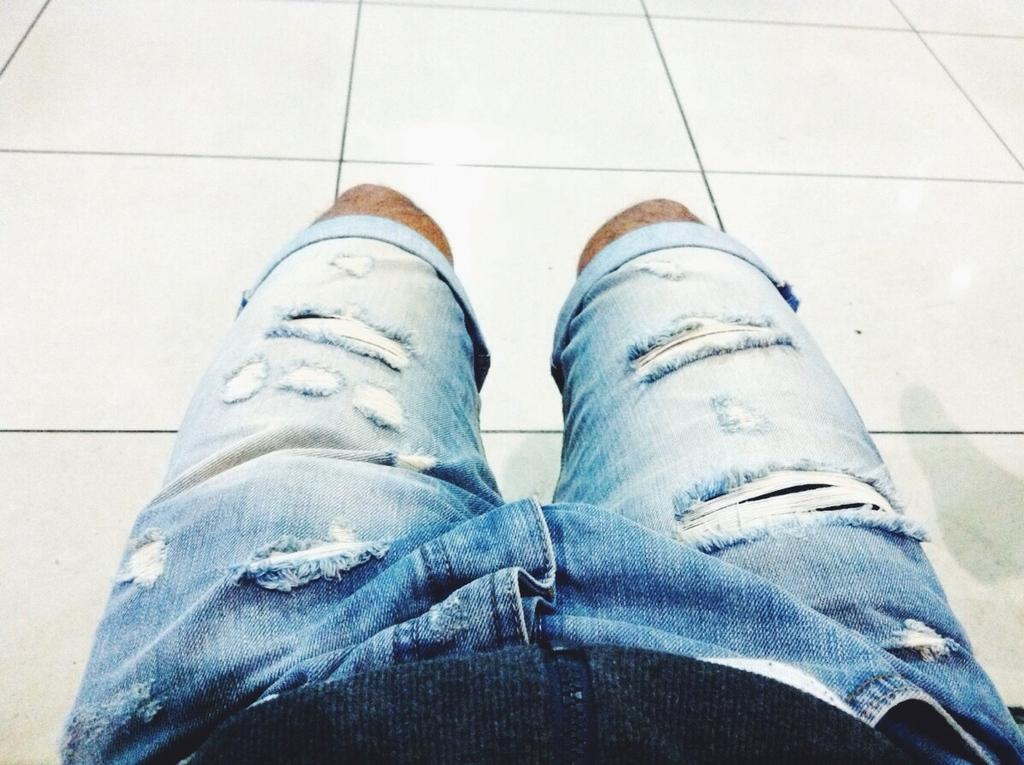What is present in the image? There is a person in the image. What type of clothing is the person wearing? The person is wearing jeans shorts. What type of flooring is visible in the image? There are tiles visible in the image. What type of jar is the person holding in the image? There is no jar present in the image; the person is not holding anything. 